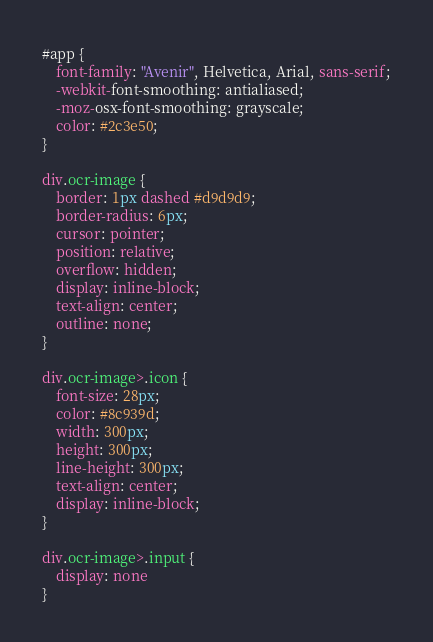<code> <loc_0><loc_0><loc_500><loc_500><_CSS_>#app {
    font-family: "Avenir", Helvetica, Arial, sans-serif;
    -webkit-font-smoothing: antialiased;
    -moz-osx-font-smoothing: grayscale;
    color: #2c3e50;
}

div.ocr-image {
    border: 1px dashed #d9d9d9;
    border-radius: 6px;
    cursor: pointer;
    position: relative;
    overflow: hidden;
    display: inline-block;
    text-align: center;
    outline: none;
}

div.ocr-image>.icon {
    font-size: 28px;
    color: #8c939d;
    width: 300px;
    height: 300px;
    line-height: 300px;
    text-align: center;
    display: inline-block;
}

div.ocr-image>.input {
    display: none
}</code> 